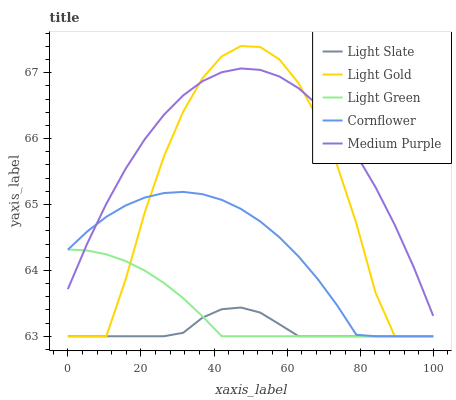Does Cornflower have the minimum area under the curve?
Answer yes or no. No. Does Cornflower have the maximum area under the curve?
Answer yes or no. No. Is Cornflower the smoothest?
Answer yes or no. No. Is Cornflower the roughest?
Answer yes or no. No. Does Medium Purple have the lowest value?
Answer yes or no. No. Does Cornflower have the highest value?
Answer yes or no. No. Is Light Slate less than Medium Purple?
Answer yes or no. Yes. Is Medium Purple greater than Light Slate?
Answer yes or no. Yes. Does Light Slate intersect Medium Purple?
Answer yes or no. No. 